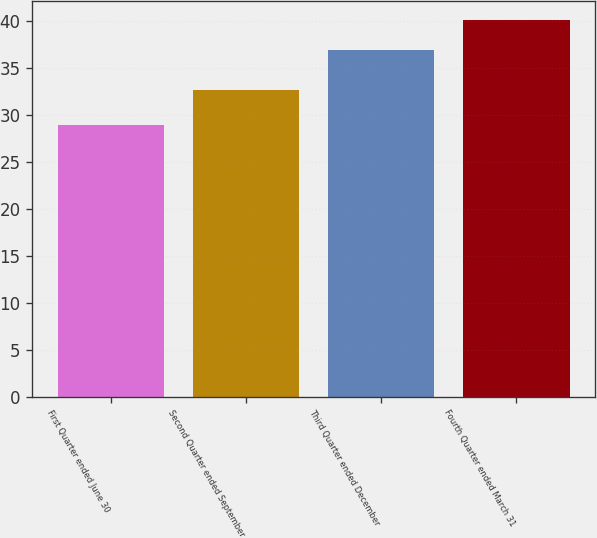Convert chart to OTSL. <chart><loc_0><loc_0><loc_500><loc_500><bar_chart><fcel>First Quarter ended June 30<fcel>Second Quarter ended September<fcel>Third Quarter ended December<fcel>Fourth Quarter ended March 31<nl><fcel>28.98<fcel>32.71<fcel>37<fcel>40.12<nl></chart> 